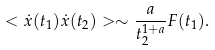Convert formula to latex. <formula><loc_0><loc_0><loc_500><loc_500>< \dot { x } ( t _ { 1 } ) \dot { x } ( t _ { 2 } ) > \sim \frac { a } { t _ { 2 } ^ { 1 + a } } F ( t _ { 1 } ) .</formula> 